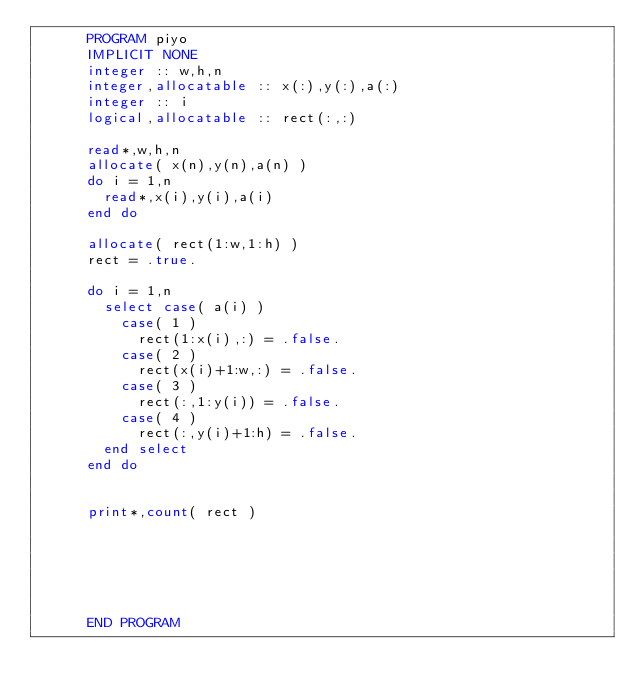Convert code to text. <code><loc_0><loc_0><loc_500><loc_500><_FORTRAN_>      PROGRAM piyo
      IMPLICIT NONE
      integer :: w,h,n
      integer,allocatable :: x(:),y(:),a(:)
      integer :: i
      logical,allocatable :: rect(:,:)
      
      read*,w,h,n
      allocate( x(n),y(n),a(n) )
      do i = 1,n
        read*,x(i),y(i),a(i)
      end do
      
      allocate( rect(1:w,1:h) )
      rect = .true.
      
      do i = 1,n
        select case( a(i) )
          case( 1 )
            rect(1:x(i),:) = .false.
          case( 2 )
            rect(x(i)+1:w,:) = .false.
          case( 3 )
            rect(:,1:y(i)) = .false.
          case( 4 )
            rect(:,y(i)+1:h) = .false.
        end select
      end do
      
      
      print*,count( rect )
      
      
      
      
      
      
      END PROGRAM</code> 